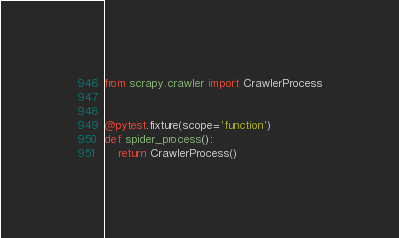Convert code to text. <code><loc_0><loc_0><loc_500><loc_500><_Python_>from scrapy.crawler import CrawlerProcess


@pytest.fixture(scope='function')
def spider_process():
    return CrawlerProcess()
</code> 